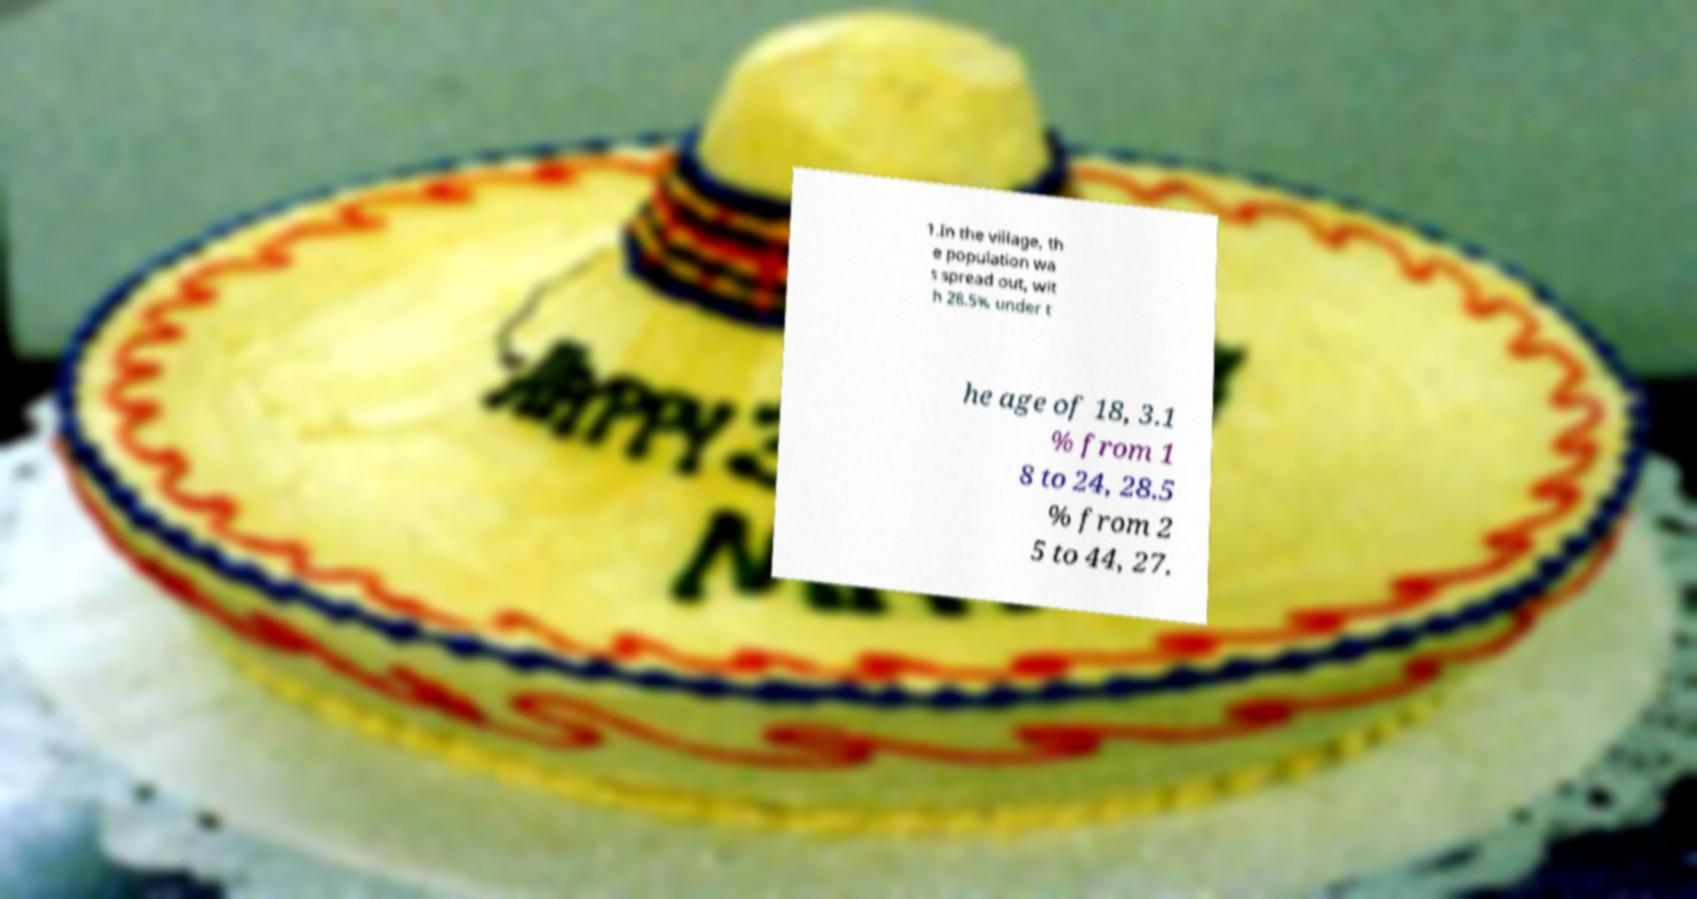What messages or text are displayed in this image? I need them in a readable, typed format. 1.In the village, th e population wa s spread out, wit h 28.5% under t he age of 18, 3.1 % from 1 8 to 24, 28.5 % from 2 5 to 44, 27. 